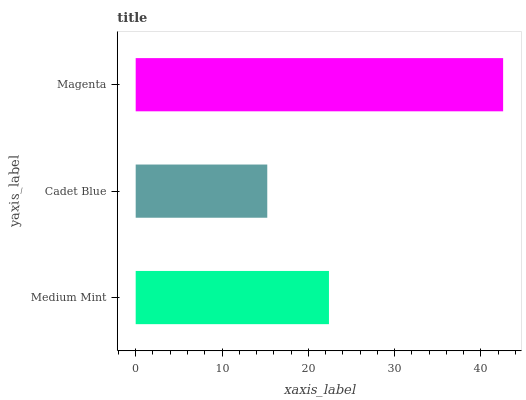Is Cadet Blue the minimum?
Answer yes or no. Yes. Is Magenta the maximum?
Answer yes or no. Yes. Is Magenta the minimum?
Answer yes or no. No. Is Cadet Blue the maximum?
Answer yes or no. No. Is Magenta greater than Cadet Blue?
Answer yes or no. Yes. Is Cadet Blue less than Magenta?
Answer yes or no. Yes. Is Cadet Blue greater than Magenta?
Answer yes or no. No. Is Magenta less than Cadet Blue?
Answer yes or no. No. Is Medium Mint the high median?
Answer yes or no. Yes. Is Medium Mint the low median?
Answer yes or no. Yes. Is Cadet Blue the high median?
Answer yes or no. No. Is Cadet Blue the low median?
Answer yes or no. No. 